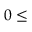<formula> <loc_0><loc_0><loc_500><loc_500>0 \leq</formula> 